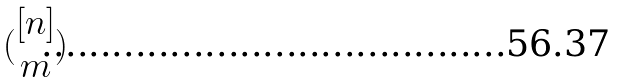Convert formula to latex. <formula><loc_0><loc_0><loc_500><loc_500>( \begin{matrix} [ n ] \\ m \end{matrix} )</formula> 